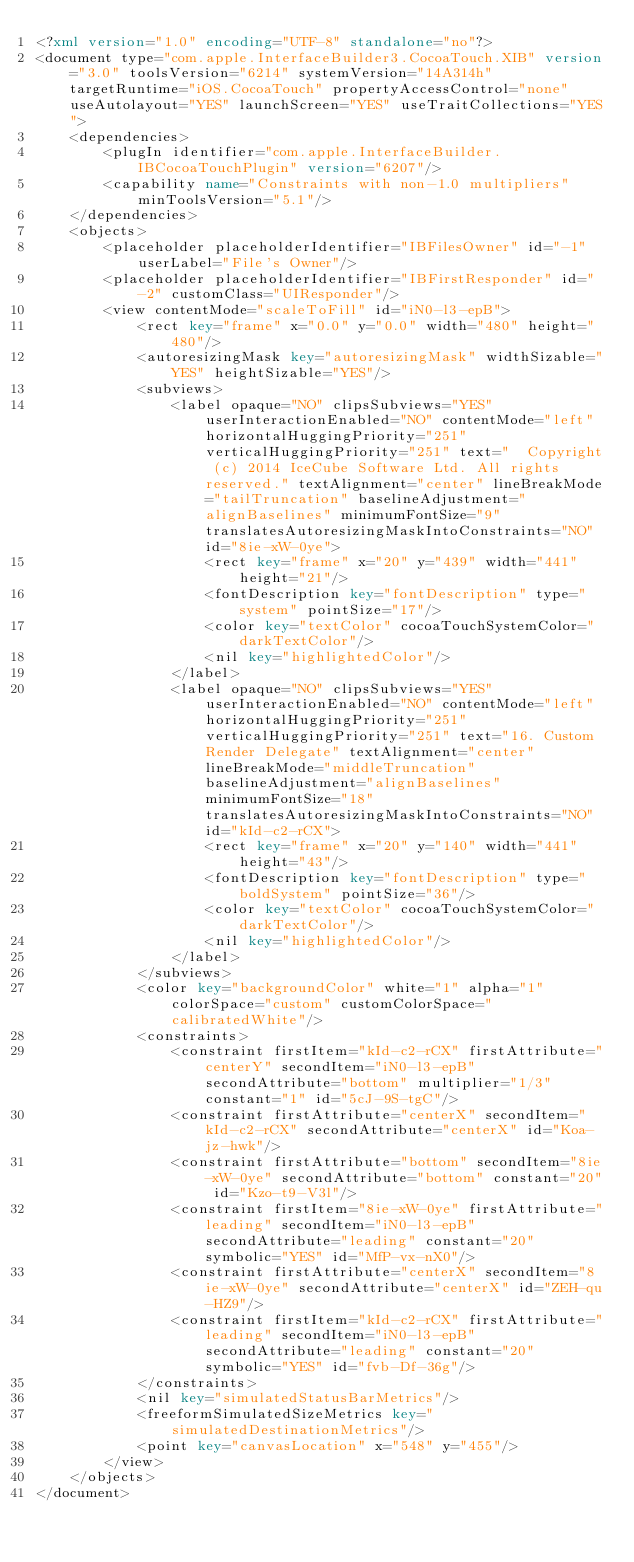<code> <loc_0><loc_0><loc_500><loc_500><_XML_><?xml version="1.0" encoding="UTF-8" standalone="no"?>
<document type="com.apple.InterfaceBuilder3.CocoaTouch.XIB" version="3.0" toolsVersion="6214" systemVersion="14A314h" targetRuntime="iOS.CocoaTouch" propertyAccessControl="none" useAutolayout="YES" launchScreen="YES" useTraitCollections="YES">
    <dependencies>
        <plugIn identifier="com.apple.InterfaceBuilder.IBCocoaTouchPlugin" version="6207"/>
        <capability name="Constraints with non-1.0 multipliers" minToolsVersion="5.1"/>
    </dependencies>
    <objects>
        <placeholder placeholderIdentifier="IBFilesOwner" id="-1" userLabel="File's Owner"/>
        <placeholder placeholderIdentifier="IBFirstResponder" id="-2" customClass="UIResponder"/>
        <view contentMode="scaleToFill" id="iN0-l3-epB">
            <rect key="frame" x="0.0" y="0.0" width="480" height="480"/>
            <autoresizingMask key="autoresizingMask" widthSizable="YES" heightSizable="YES"/>
            <subviews>
                <label opaque="NO" clipsSubviews="YES" userInteractionEnabled="NO" contentMode="left" horizontalHuggingPriority="251" verticalHuggingPriority="251" text="  Copyright (c) 2014 IceCube Software Ltd. All rights reserved." textAlignment="center" lineBreakMode="tailTruncation" baselineAdjustment="alignBaselines" minimumFontSize="9" translatesAutoresizingMaskIntoConstraints="NO" id="8ie-xW-0ye">
                    <rect key="frame" x="20" y="439" width="441" height="21"/>
                    <fontDescription key="fontDescription" type="system" pointSize="17"/>
                    <color key="textColor" cocoaTouchSystemColor="darkTextColor"/>
                    <nil key="highlightedColor"/>
                </label>
                <label opaque="NO" clipsSubviews="YES" userInteractionEnabled="NO" contentMode="left" horizontalHuggingPriority="251" verticalHuggingPriority="251" text="16. Custom Render Delegate" textAlignment="center" lineBreakMode="middleTruncation" baselineAdjustment="alignBaselines" minimumFontSize="18" translatesAutoresizingMaskIntoConstraints="NO" id="kId-c2-rCX">
                    <rect key="frame" x="20" y="140" width="441" height="43"/>
                    <fontDescription key="fontDescription" type="boldSystem" pointSize="36"/>
                    <color key="textColor" cocoaTouchSystemColor="darkTextColor"/>
                    <nil key="highlightedColor"/>
                </label>
            </subviews>
            <color key="backgroundColor" white="1" alpha="1" colorSpace="custom" customColorSpace="calibratedWhite"/>
            <constraints>
                <constraint firstItem="kId-c2-rCX" firstAttribute="centerY" secondItem="iN0-l3-epB" secondAttribute="bottom" multiplier="1/3" constant="1" id="5cJ-9S-tgC"/>
                <constraint firstAttribute="centerX" secondItem="kId-c2-rCX" secondAttribute="centerX" id="Koa-jz-hwk"/>
                <constraint firstAttribute="bottom" secondItem="8ie-xW-0ye" secondAttribute="bottom" constant="20" id="Kzo-t9-V3l"/>
                <constraint firstItem="8ie-xW-0ye" firstAttribute="leading" secondItem="iN0-l3-epB" secondAttribute="leading" constant="20" symbolic="YES" id="MfP-vx-nX0"/>
                <constraint firstAttribute="centerX" secondItem="8ie-xW-0ye" secondAttribute="centerX" id="ZEH-qu-HZ9"/>
                <constraint firstItem="kId-c2-rCX" firstAttribute="leading" secondItem="iN0-l3-epB" secondAttribute="leading" constant="20" symbolic="YES" id="fvb-Df-36g"/>
            </constraints>
            <nil key="simulatedStatusBarMetrics"/>
            <freeformSimulatedSizeMetrics key="simulatedDestinationMetrics"/>
            <point key="canvasLocation" x="548" y="455"/>
        </view>
    </objects>
</document>
</code> 